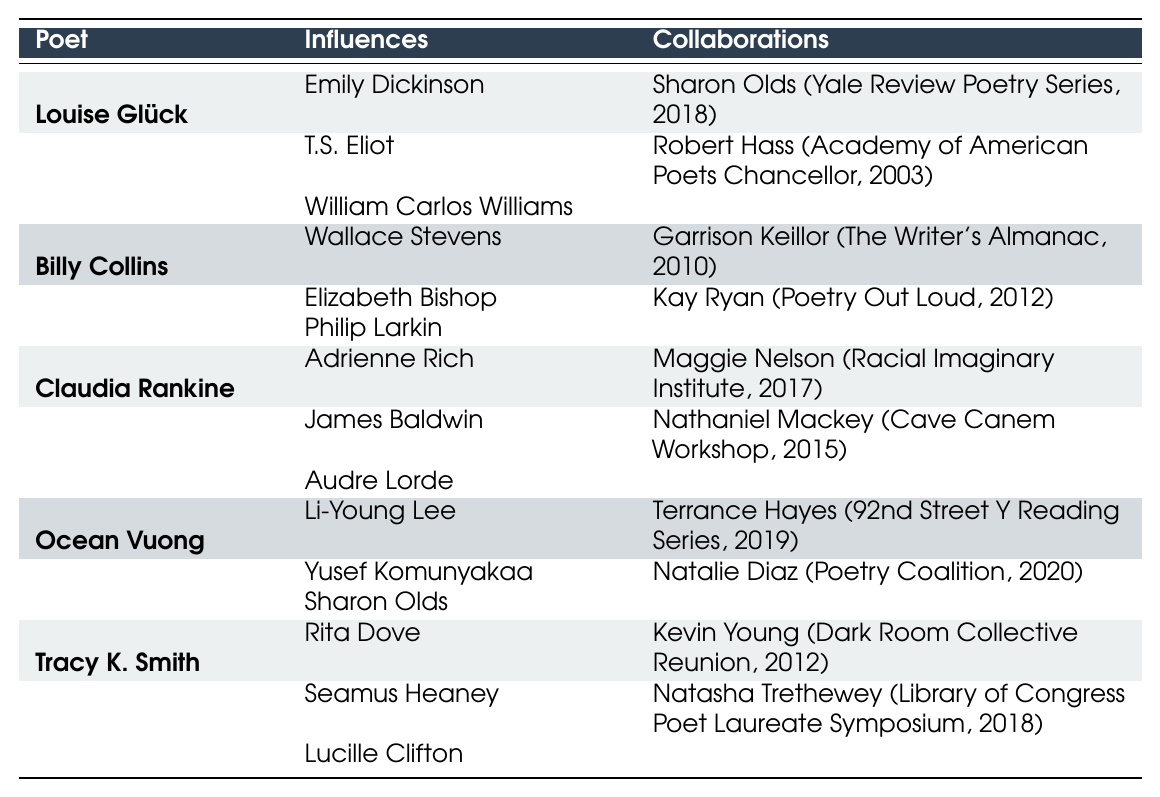What influences are attributed to Louise Glück? The table lists the influences of Louise Glück as Emily Dickinson, T.S. Eliot, and William Carlos Williams.
Answer: Emily Dickinson, T.S. Eliot, William Carlos Williams Who did Billy Collins collaborate with in 2010? According to the table, Billy Collins collaborated with Garrison Keillor on "The Writer's Almanac" in 2010.
Answer: Garrison Keillor How many collaborations does Tracy K. Smith have listed? The table indicates that Tracy K. Smith has two collaborations listed: one with Kevin Young and another with Natasha Trethewey.
Answer: 2 Do any poets in the table list Sharon Olds as an influence? By reviewing the influences, it can be seen that both Ocean Vuong and Louise Glück list Sharon Olds as an influence.
Answer: Yes Which poets have collaborated with Kay Ryan? The table shows that Billy Collins collaborated with Kay Ryan on "Poetry Out Loud" in 2012.
Answer: Billy Collins What is the total number of influences listed for Claudia Rankine? The table details three influences for Claudia Rankine: Adrienne Rich, James Baldwin, and Audre Lorde. Thus, the total is 3.
Answer: 3 Which poet influenced both Ocean Vuong and Louise Glück? By examining their influences, it is clear that Sharon Olds is listed as an influence for both poets.
Answer: Sharon Olds In which year did Tracy K. Smith collaborate with Natasha Trethewey? The table specifies that Tracy K. Smith collaborated with Natasha Trethewey in the year 2018 for the Library of Congress Poet Laureate Symposium.
Answer: 2018 What is the average number of collaborations per poet listed in the table? Each poet in the table has 2 collaborations. With 5 poets in total, the average is calculated as (2 + 2 + 2 + 2 + 2) / 5 = 2.
Answer: 2 Is there any overlap in influences among the poets listed in the table? Upon close inspection, it can be seen that some poets have shared influences, such as Sharon Olds influencing both Ocean Vuong and Louise Glück.
Answer: Yes 